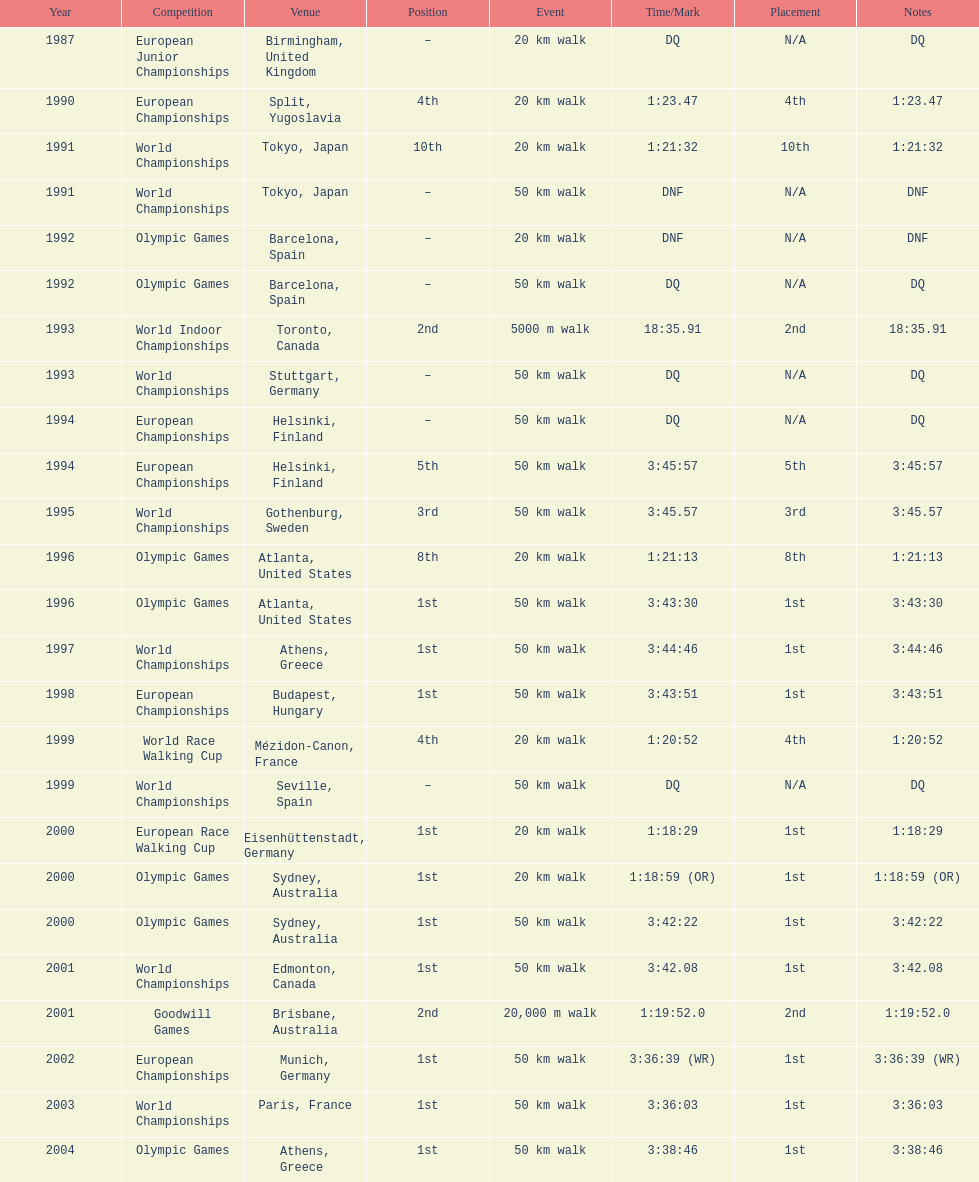In 1990 what position did robert korzeniowski place? 4th. In 1993 what was robert korzeniowski's place in the world indoor championships? 2nd. How long did the 50km walk in 2004 olympic cost? 3:38:46. 